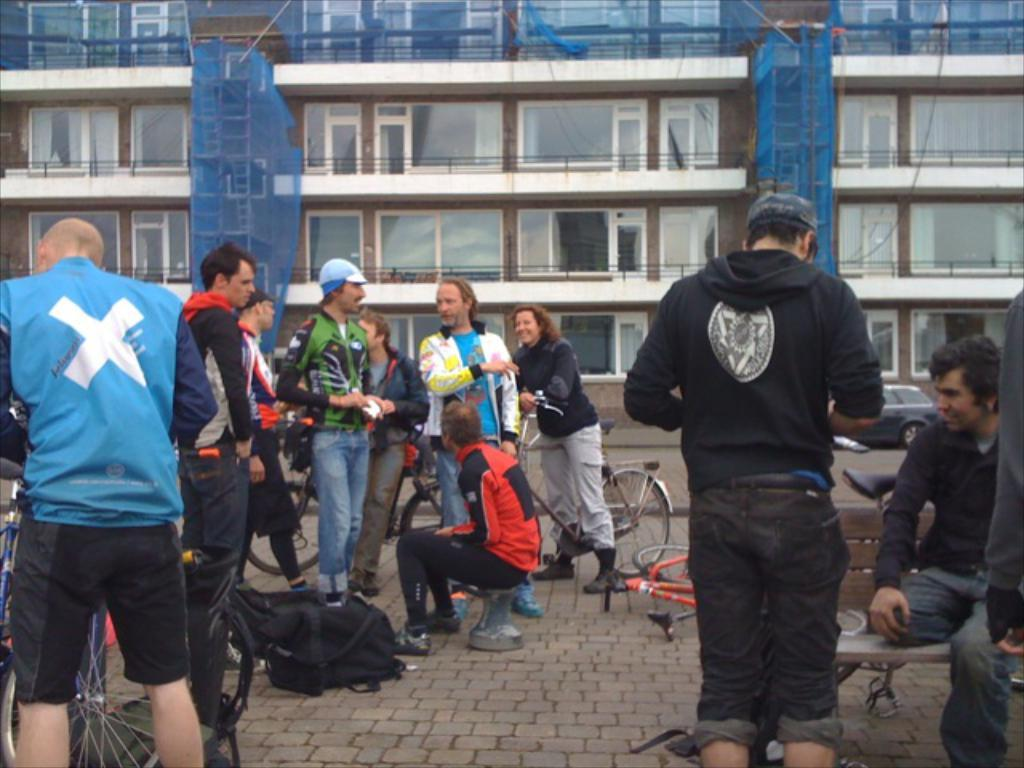What are the people in the image doing? There is a group of people standing in the image, and some people are riding bicycles. Can you describe the background of the image? There is a building in the background of the image. What type of coat is the beetle wearing in the image? There is no beetle present in the image, and therefore no coat can be observed. 